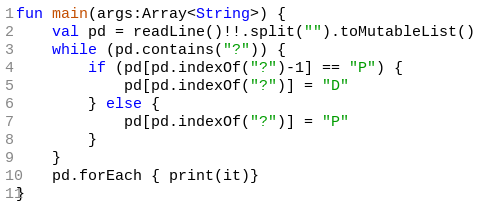Convert code to text. <code><loc_0><loc_0><loc_500><loc_500><_Kotlin_>fun main(args:Array<String>) {
    val pd = readLine()!!.split("").toMutableList()
    while (pd.contains("?")) {
        if (pd[pd.indexOf("?")-1] == "P") {
            pd[pd.indexOf("?")] = "D"
        } else {
            pd[pd.indexOf("?")] = "P"
        }
    }
    pd.forEach { print(it)}
}</code> 